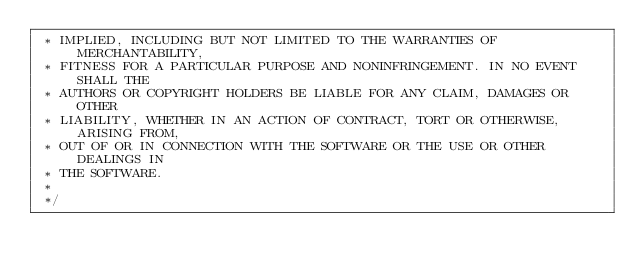Convert code to text. <code><loc_0><loc_0><loc_500><loc_500><_Cuda_> * IMPLIED, INCLUDING BUT NOT LIMITED TO THE WARRANTIES OF MERCHANTABILITY,
 * FITNESS FOR A PARTICULAR PURPOSE AND NONINFRINGEMENT. IN NO EVENT SHALL THE
 * AUTHORS OR COPYRIGHT HOLDERS BE LIABLE FOR ANY CLAIM, DAMAGES OR OTHER
 * LIABILITY, WHETHER IN AN ACTION OF CONTRACT, TORT OR OTHERWISE, ARISING FROM,
 * OUT OF OR IN CONNECTION WITH THE SOFTWARE OR THE USE OR OTHER DEALINGS IN
 * THE SOFTWARE.
 *
 */
</code> 